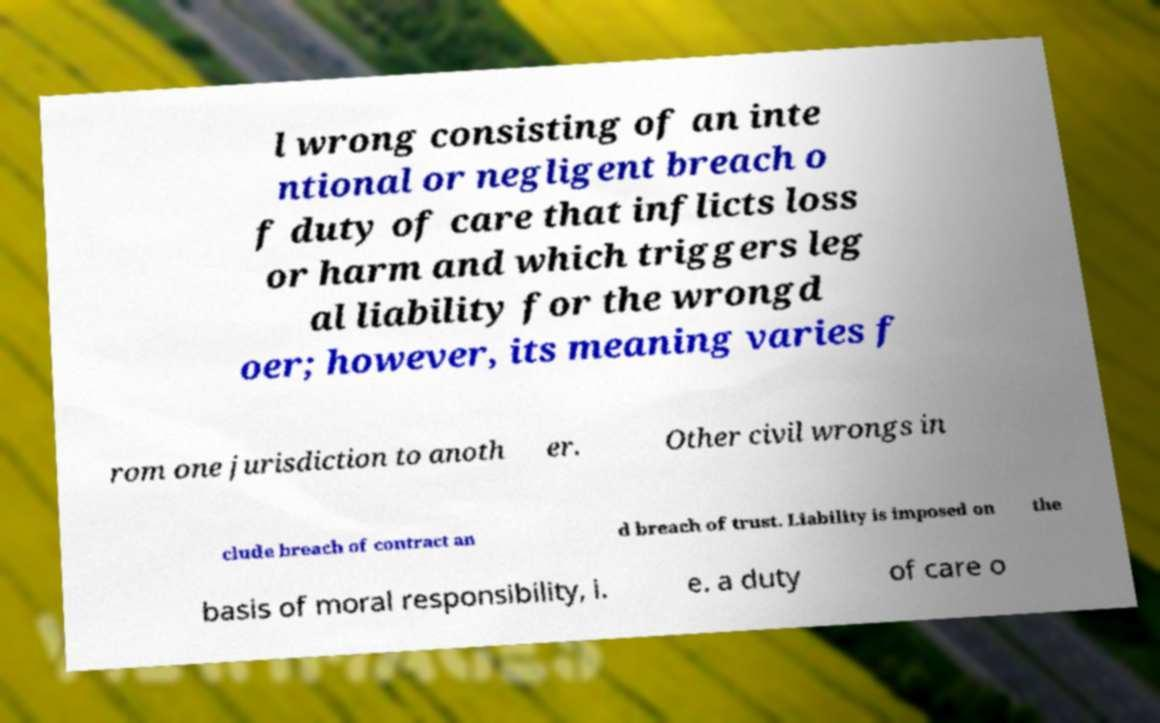There's text embedded in this image that I need extracted. Can you transcribe it verbatim? l wrong consisting of an inte ntional or negligent breach o f duty of care that inflicts loss or harm and which triggers leg al liability for the wrongd oer; however, its meaning varies f rom one jurisdiction to anoth er. Other civil wrongs in clude breach of contract an d breach of trust. Liability is imposed on the basis of moral responsibility, i. e. a duty of care o 